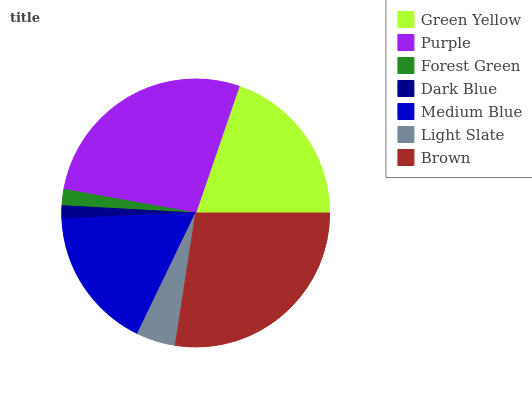Is Dark Blue the minimum?
Answer yes or no. Yes. Is Purple the maximum?
Answer yes or no. Yes. Is Forest Green the minimum?
Answer yes or no. No. Is Forest Green the maximum?
Answer yes or no. No. Is Purple greater than Forest Green?
Answer yes or no. Yes. Is Forest Green less than Purple?
Answer yes or no. Yes. Is Forest Green greater than Purple?
Answer yes or no. No. Is Purple less than Forest Green?
Answer yes or no. No. Is Medium Blue the high median?
Answer yes or no. Yes. Is Medium Blue the low median?
Answer yes or no. Yes. Is Light Slate the high median?
Answer yes or no. No. Is Purple the low median?
Answer yes or no. No. 